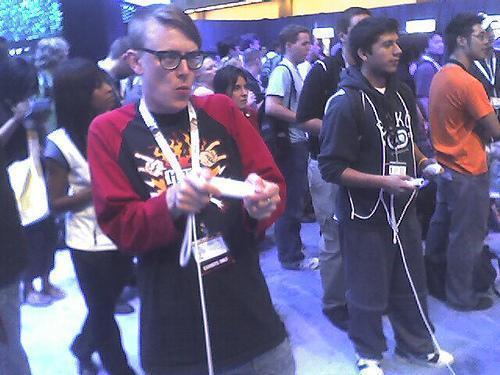What are the people in the front holding?
Indicate the correct choice and explain in the format: 'Answer: answer
Rationale: rationale.'
Options: Controllers, puppies, umbrellas, kittens. Answer: controllers.
Rationale: The people have controllers. 